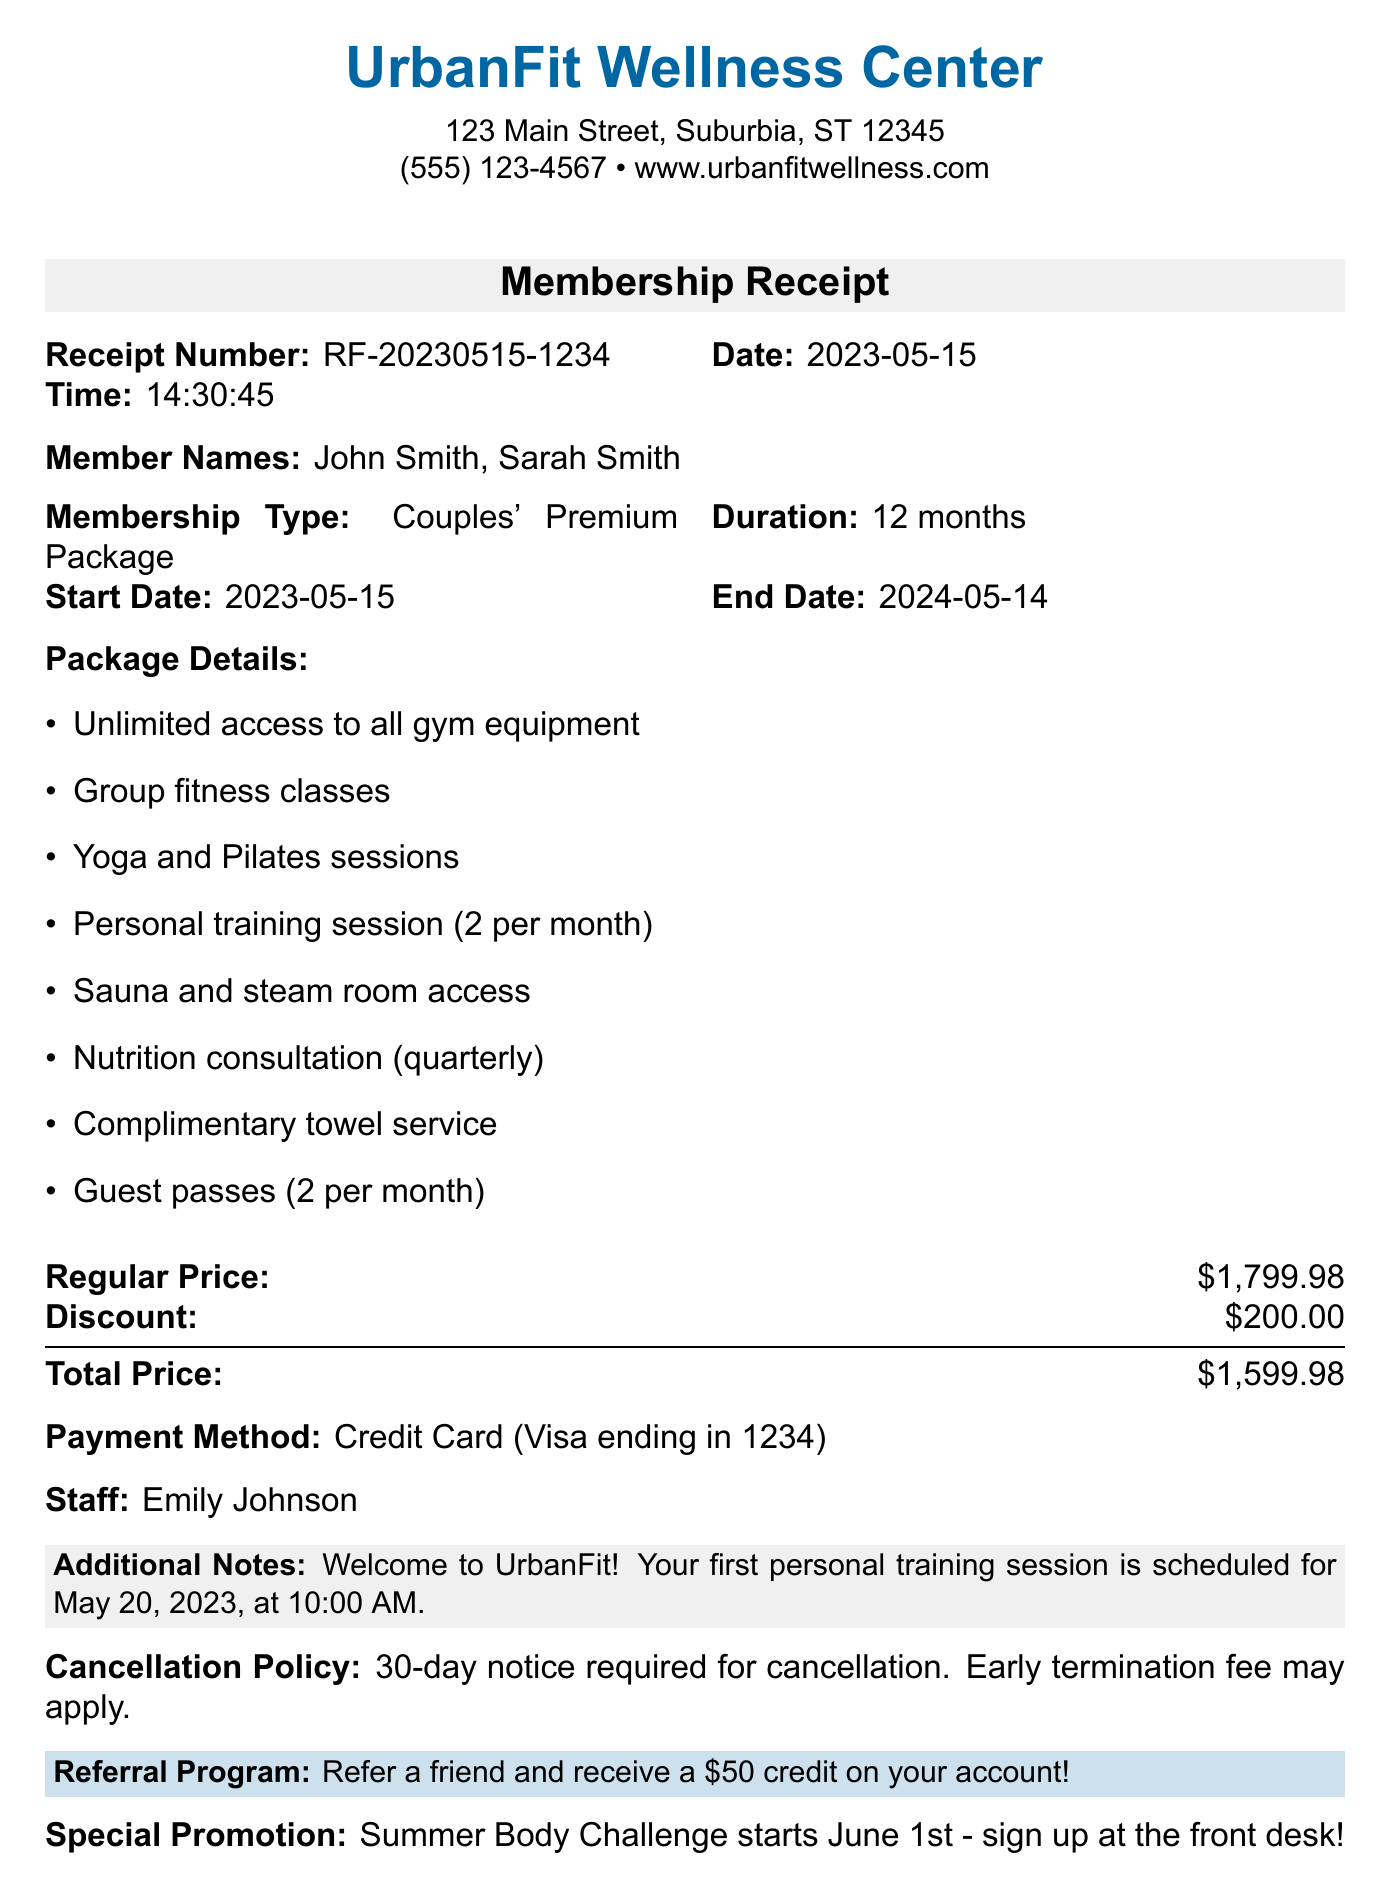What is the gym's address? The gym's address is stated clearly in the document as part of the contact information.
Answer: 123 Main Street, Suburbia, ST 12345 Who are the members? The receipt lists the names of the members enrolled in the couples' package.
Answer: John Smith, Sarah Smith What is the membership type? The type of membership is explicitly mentioned in the document under membership details.
Answer: Couples' Premium Package What is the total price after discount? The document provides the regular price and discount, allowing for this straightforward calculation.
Answer: $1,599.98 When does the membership end? The end date of the membership is clearly noted in the membership details section.
Answer: 2024-05-14 How many personal training sessions are included per month? The document states the number of sessions provided in the package details.
Answer: 2 per month What is the cancellation policy? The document specifies the requirements for canceling the membership.
Answer: 30-day notice required for cancellation What is the discount amount? The document specifies the discount amount applied to the membership price.
Answer: $200.00 What special promotion is mentioned? The document highlights an upcoming promotion that is informative for members.
Answer: Summer Body Challenge starts June 1st 